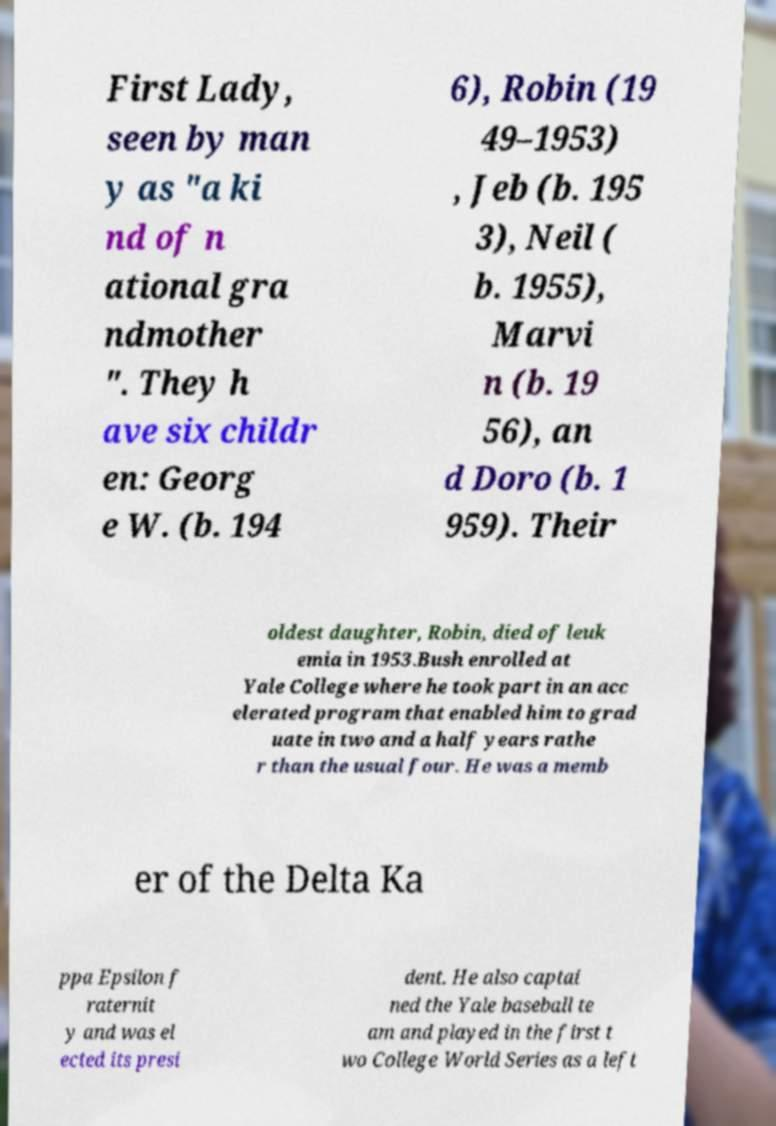There's text embedded in this image that I need extracted. Can you transcribe it verbatim? First Lady, seen by man y as "a ki nd of n ational gra ndmother ". They h ave six childr en: Georg e W. (b. 194 6), Robin (19 49–1953) , Jeb (b. 195 3), Neil ( b. 1955), Marvi n (b. 19 56), an d Doro (b. 1 959). Their oldest daughter, Robin, died of leuk emia in 1953.Bush enrolled at Yale College where he took part in an acc elerated program that enabled him to grad uate in two and a half years rathe r than the usual four. He was a memb er of the Delta Ka ppa Epsilon f raternit y and was el ected its presi dent. He also captai ned the Yale baseball te am and played in the first t wo College World Series as a left 